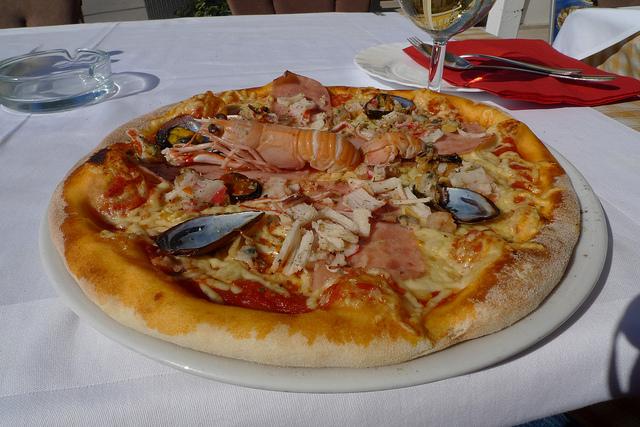Does anything need to be removed from the pizza before it is eaten?
Write a very short answer. Yes. Is the pizza delicious?
Short answer required. Yes. Is there any meat on this pizza?
Write a very short answer. Yes. Does the pizza have seafood toppings?
Quick response, please. Yes. What is on the pizza?
Answer briefly. Seafood. What are the black things on the pizza?
Give a very brief answer. Oysters. Is any of the pizza burnt?
Write a very short answer. No. Where is the wine glass?
Give a very brief answer. Table. Is the pizza on a plate or paper?
Be succinct. Plate. What kind of toppings are on the pizza?
Quick response, please. Seafood. What is the most prominent topping?
Answer briefly. Cheese. Is there a prawn on the pizza?
Keep it brief. Yes. 